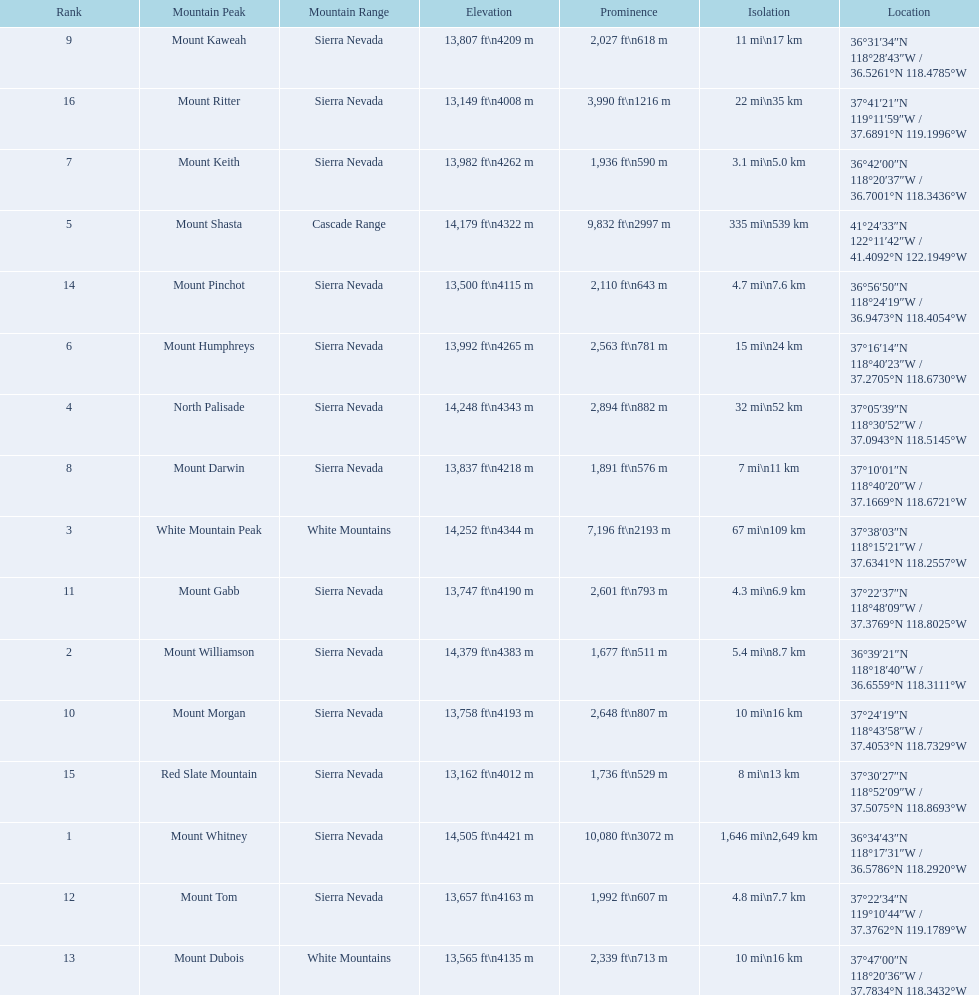What are all of the mountain peaks? Mount Whitney, Mount Williamson, White Mountain Peak, North Palisade, Mount Shasta, Mount Humphreys, Mount Keith, Mount Darwin, Mount Kaweah, Mount Morgan, Mount Gabb, Mount Tom, Mount Dubois, Mount Pinchot, Red Slate Mountain, Mount Ritter. In what ranges are they located? Sierra Nevada, Sierra Nevada, White Mountains, Sierra Nevada, Cascade Range, Sierra Nevada, Sierra Nevada, Sierra Nevada, Sierra Nevada, Sierra Nevada, Sierra Nevada, Sierra Nevada, White Mountains, Sierra Nevada, Sierra Nevada, Sierra Nevada. And which mountain peak is in the cascade range? Mount Shasta. 